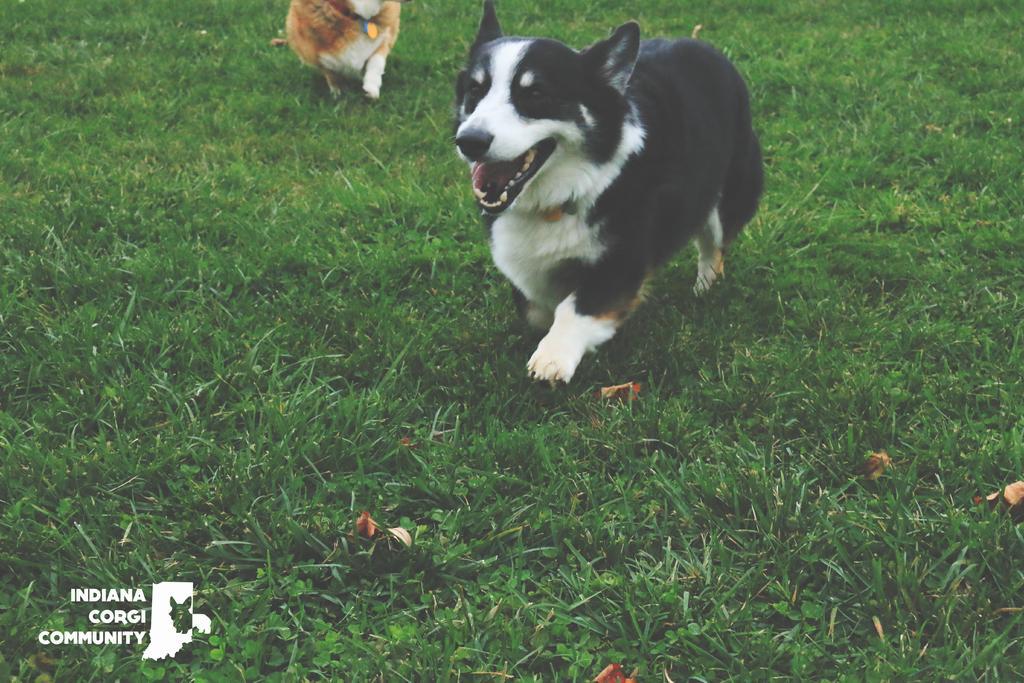Could you give a brief overview of what you see in this image? In this image, we can see a dog is running on the grass. Top of the image, we can see an animal. Left side bottom, there is a watermark and icon in the image. 